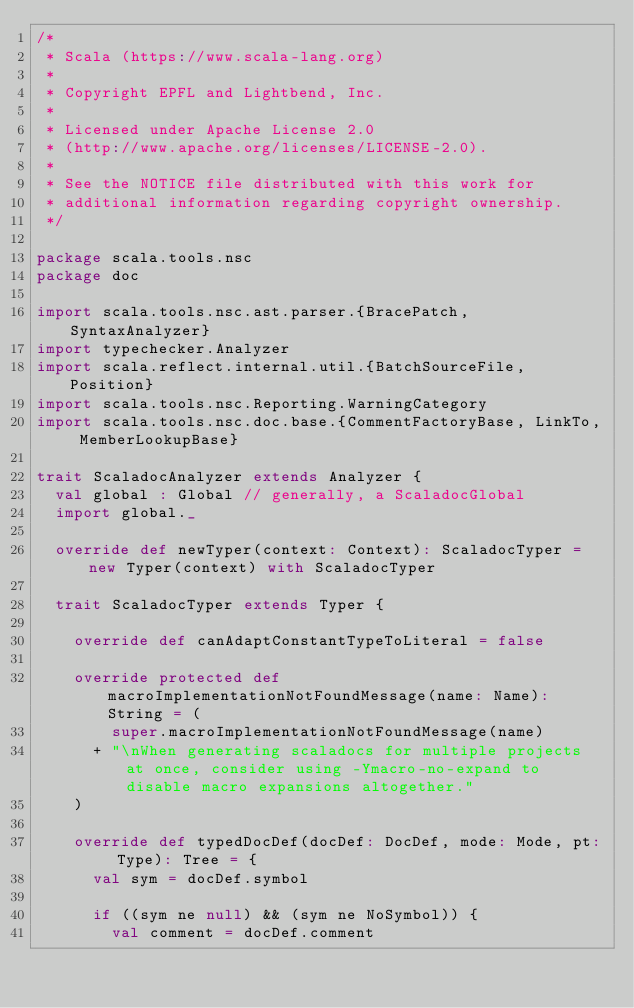Convert code to text. <code><loc_0><loc_0><loc_500><loc_500><_Scala_>/*
 * Scala (https://www.scala-lang.org)
 *
 * Copyright EPFL and Lightbend, Inc.
 *
 * Licensed under Apache License 2.0
 * (http://www.apache.org/licenses/LICENSE-2.0).
 *
 * See the NOTICE file distributed with this work for
 * additional information regarding copyright ownership.
 */

package scala.tools.nsc
package doc

import scala.tools.nsc.ast.parser.{BracePatch, SyntaxAnalyzer}
import typechecker.Analyzer
import scala.reflect.internal.util.{BatchSourceFile, Position}
import scala.tools.nsc.Reporting.WarningCategory
import scala.tools.nsc.doc.base.{CommentFactoryBase, LinkTo, MemberLookupBase}

trait ScaladocAnalyzer extends Analyzer {
  val global : Global // generally, a ScaladocGlobal
  import global._

  override def newTyper(context: Context): ScaladocTyper = new Typer(context) with ScaladocTyper

  trait ScaladocTyper extends Typer {

    override def canAdaptConstantTypeToLiteral = false

    override protected def macroImplementationNotFoundMessage(name: Name): String = (
        super.macroImplementationNotFoundMessage(name)
      + "\nWhen generating scaladocs for multiple projects at once, consider using -Ymacro-no-expand to disable macro expansions altogether."
    )

    override def typedDocDef(docDef: DocDef, mode: Mode, pt: Type): Tree = {
      val sym = docDef.symbol

      if ((sym ne null) && (sym ne NoSymbol)) {
        val comment = docDef.comment</code> 